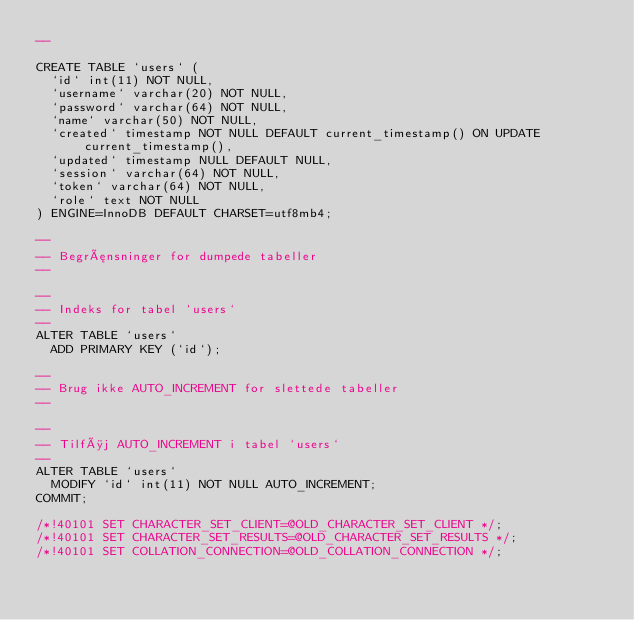<code> <loc_0><loc_0><loc_500><loc_500><_SQL_>--

CREATE TABLE `users` (
  `id` int(11) NOT NULL,
  `username` varchar(20) NOT NULL,
  `password` varchar(64) NOT NULL,
  `name` varchar(50) NOT NULL,
  `created` timestamp NOT NULL DEFAULT current_timestamp() ON UPDATE current_timestamp(),
  `updated` timestamp NULL DEFAULT NULL,
  `session` varchar(64) NOT NULL,
  `token` varchar(64) NOT NULL,
  `role` text NOT NULL
) ENGINE=InnoDB DEFAULT CHARSET=utf8mb4;

--
-- Begrænsninger for dumpede tabeller
--

--
-- Indeks for tabel `users`
--
ALTER TABLE `users`
  ADD PRIMARY KEY (`id`);

--
-- Brug ikke AUTO_INCREMENT for slettede tabeller
--

--
-- Tilføj AUTO_INCREMENT i tabel `users`
--
ALTER TABLE `users`
  MODIFY `id` int(11) NOT NULL AUTO_INCREMENT;
COMMIT;

/*!40101 SET CHARACTER_SET_CLIENT=@OLD_CHARACTER_SET_CLIENT */;
/*!40101 SET CHARACTER_SET_RESULTS=@OLD_CHARACTER_SET_RESULTS */;
/*!40101 SET COLLATION_CONNECTION=@OLD_COLLATION_CONNECTION */;
</code> 